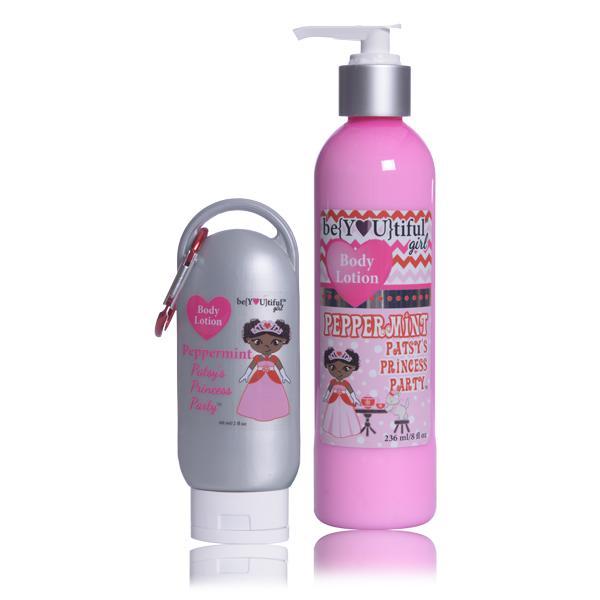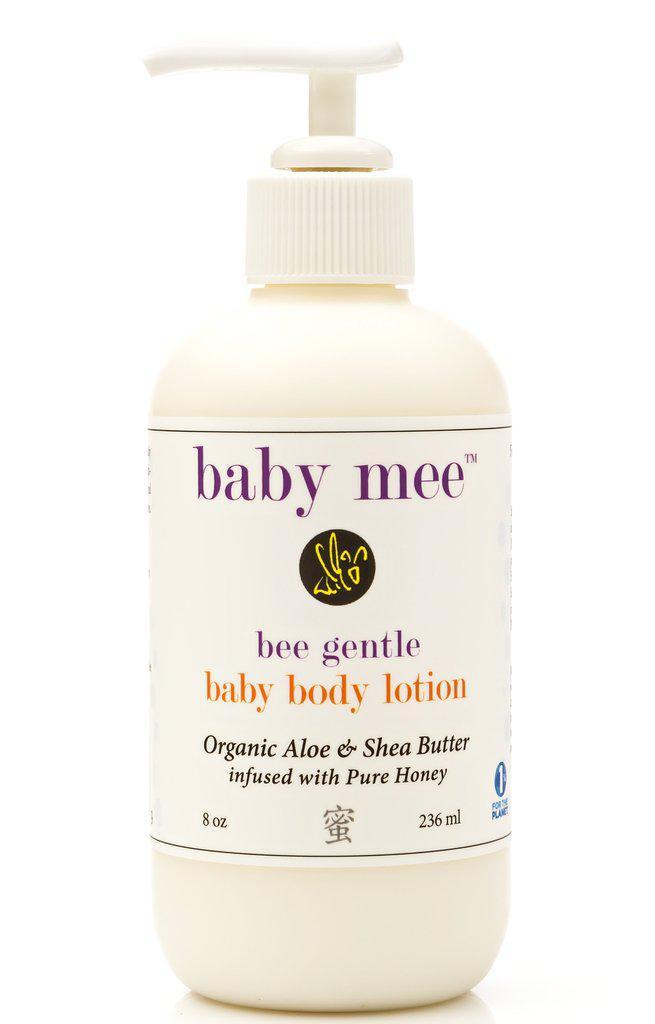The first image is the image on the left, the second image is the image on the right. Assess this claim about the two images: "The lefthand image includes a pump-applicator bottle, while the right image contains at least four versions of one product that doesn't have a pump top.". Correct or not? Answer yes or no. No. 